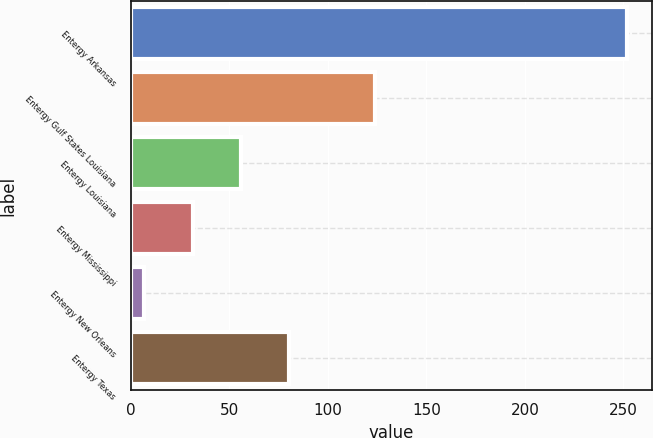Convert chart to OTSL. <chart><loc_0><loc_0><loc_500><loc_500><bar_chart><fcel>Entergy Arkansas<fcel>Entergy Gulf States Louisiana<fcel>Entergy Louisiana<fcel>Entergy Mississippi<fcel>Entergy New Orleans<fcel>Entergy Texas<nl><fcel>252<fcel>124<fcel>56<fcel>31.5<fcel>7<fcel>80.5<nl></chart> 